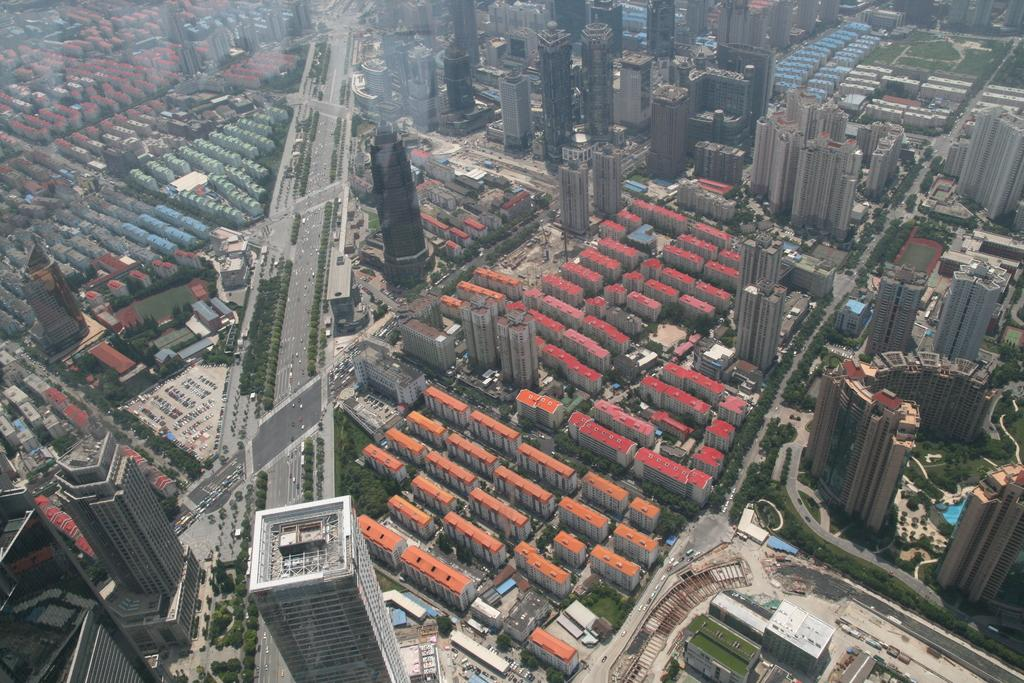What type of structures can be seen in the image? There are buildings in the image. What natural elements are present in the image? There are trees in the image. What type of man-made paths are visible in the image? There are roads in the image. What type of mint can be seen growing near the buildings in the image? There is no mint present in the image; it only features buildings, trees, and roads. 